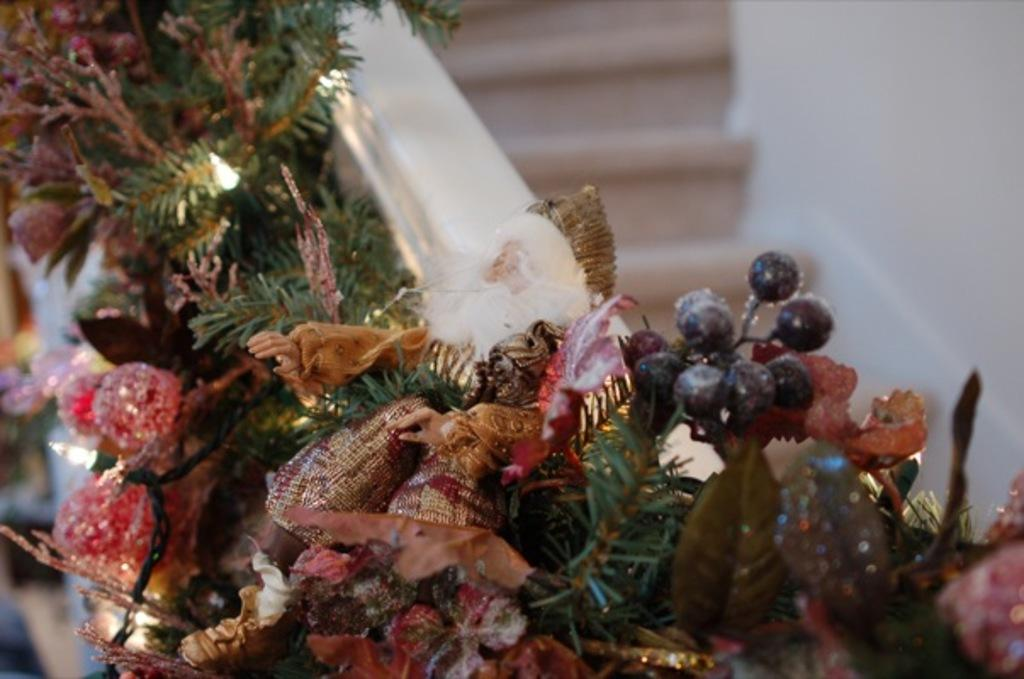What type of vegetation can be seen in the image? There are green leaves in the image. What else is present in the image besides the green leaves? There is decoration visible in the image. What color is the wall in the image? There is a white wall in the image. How much sugar is present in the rainstorm depicted in the image? There is no rainstorm depicted in the image, and therefore no sugar can be associated with it. 